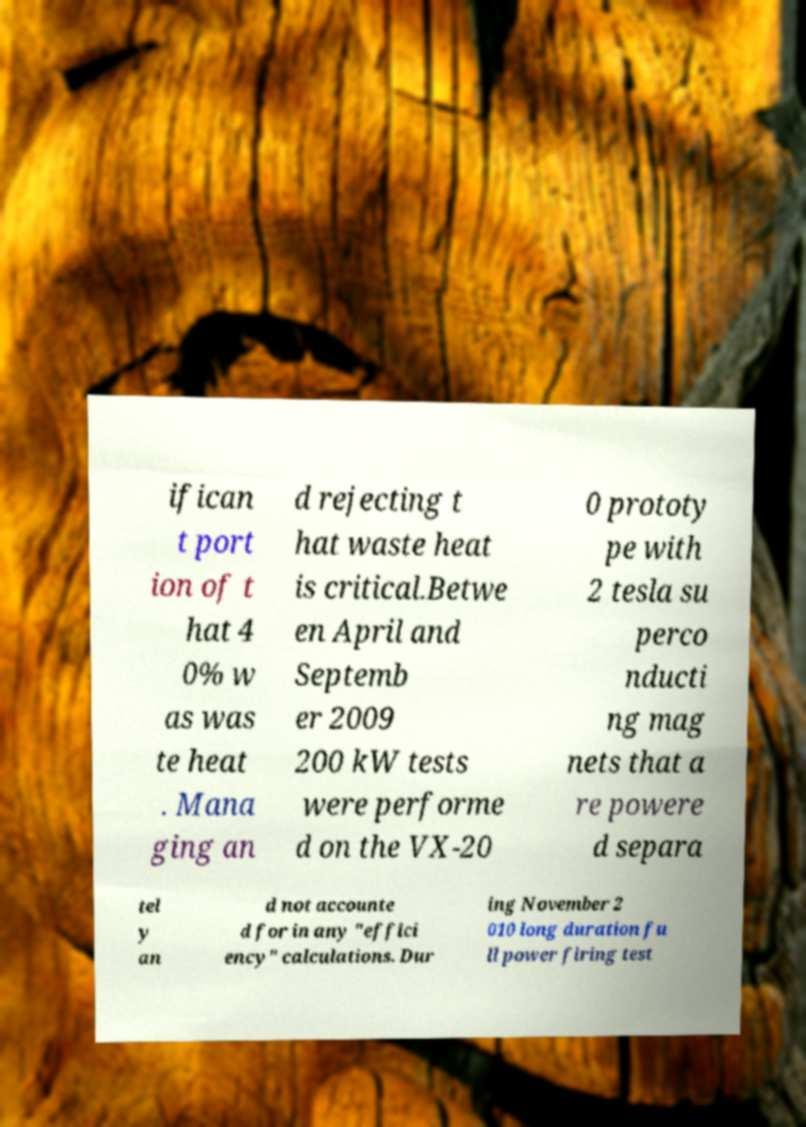I need the written content from this picture converted into text. Can you do that? ifican t port ion of t hat 4 0% w as was te heat . Mana ging an d rejecting t hat waste heat is critical.Betwe en April and Septemb er 2009 200 kW tests were performe d on the VX-20 0 prototy pe with 2 tesla su perco nducti ng mag nets that a re powere d separa tel y an d not accounte d for in any "effici ency" calculations. Dur ing November 2 010 long duration fu ll power firing test 